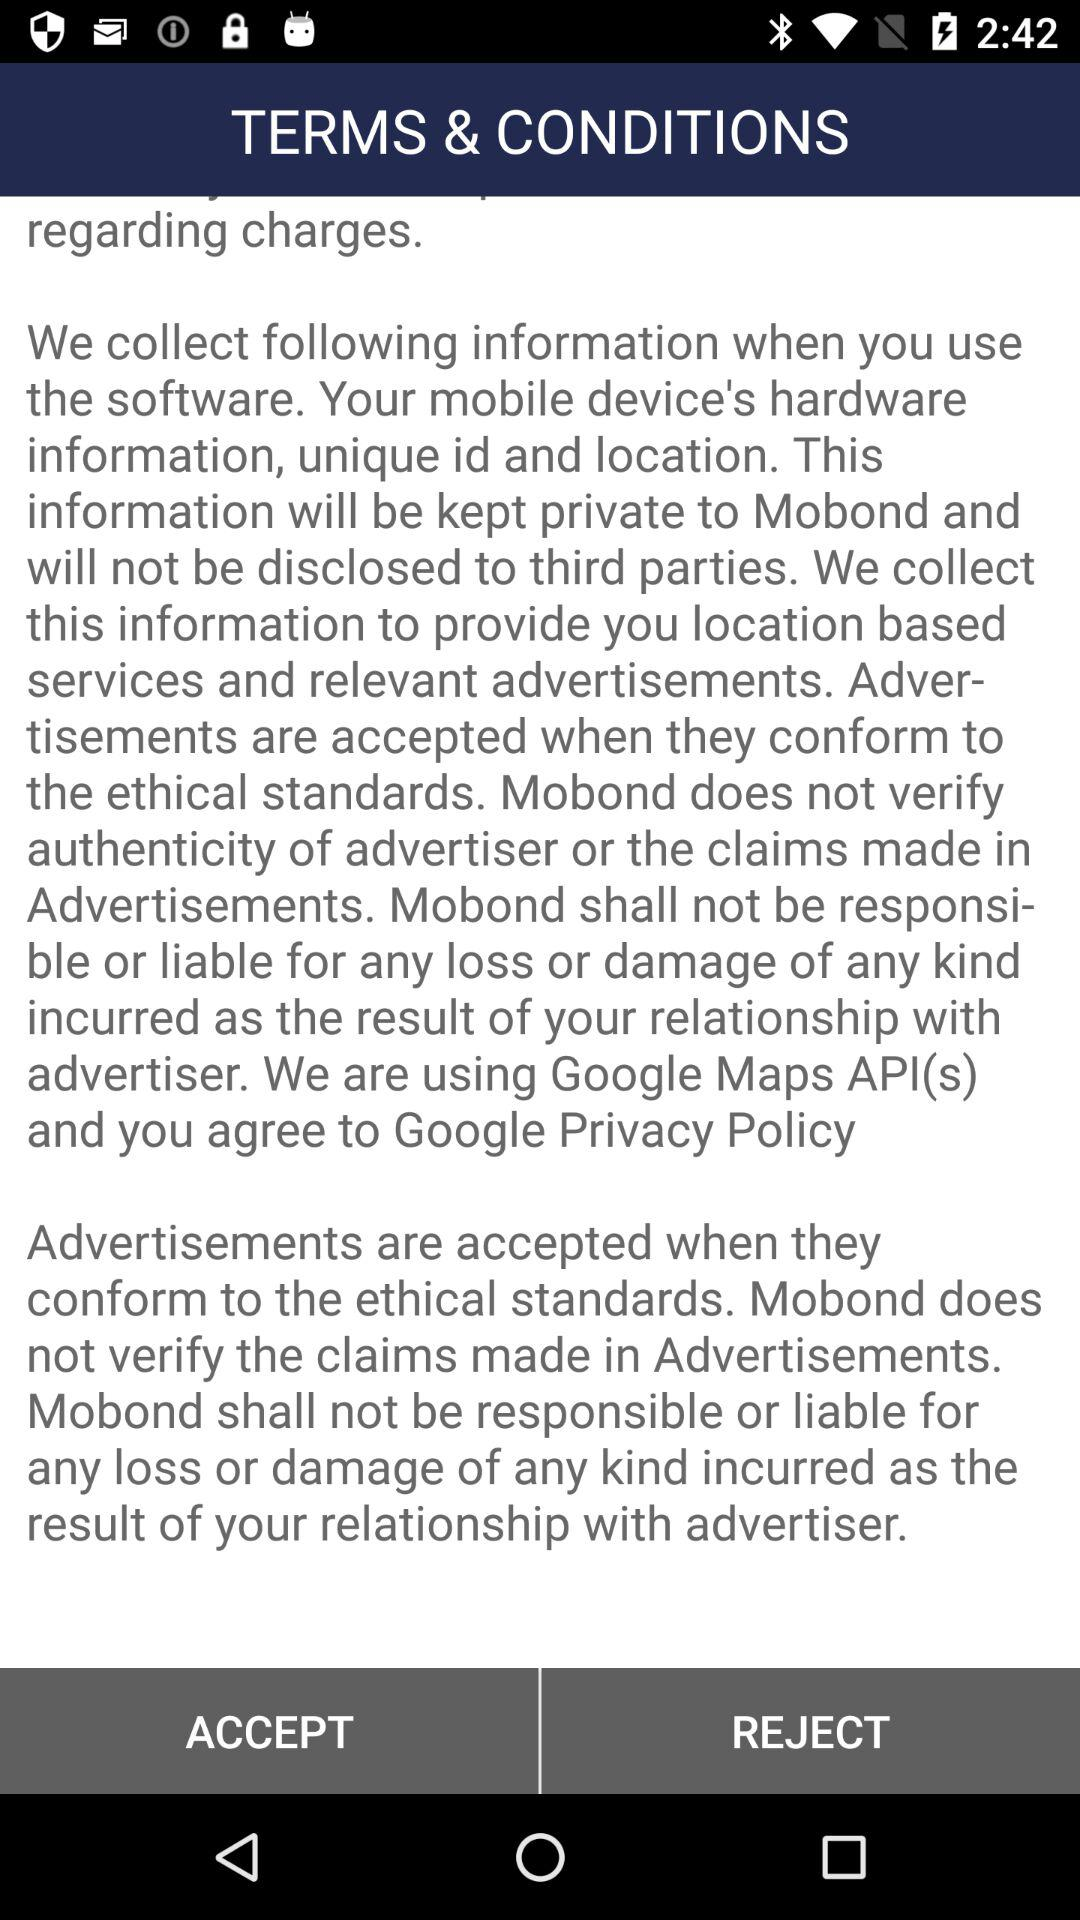What is the version? The version is 13.1.86. 